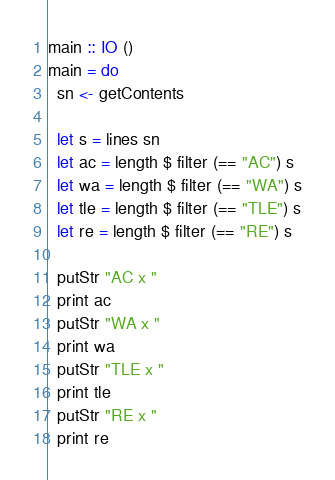<code> <loc_0><loc_0><loc_500><loc_500><_Haskell_>main :: IO ()
main = do
  sn <- getContents
  
  let s = lines sn
  let ac = length $ filter (== "AC") s
  let wa = length $ filter (== "WA") s
  let tle = length $ filter (== "TLE") s
  let re = length $ filter (== "RE") s
  
  putStr "AC x "
  print ac
  putStr "WA x "
  print wa
  putStr "TLE x "
  print tle
  putStr "RE x "
  print re</code> 